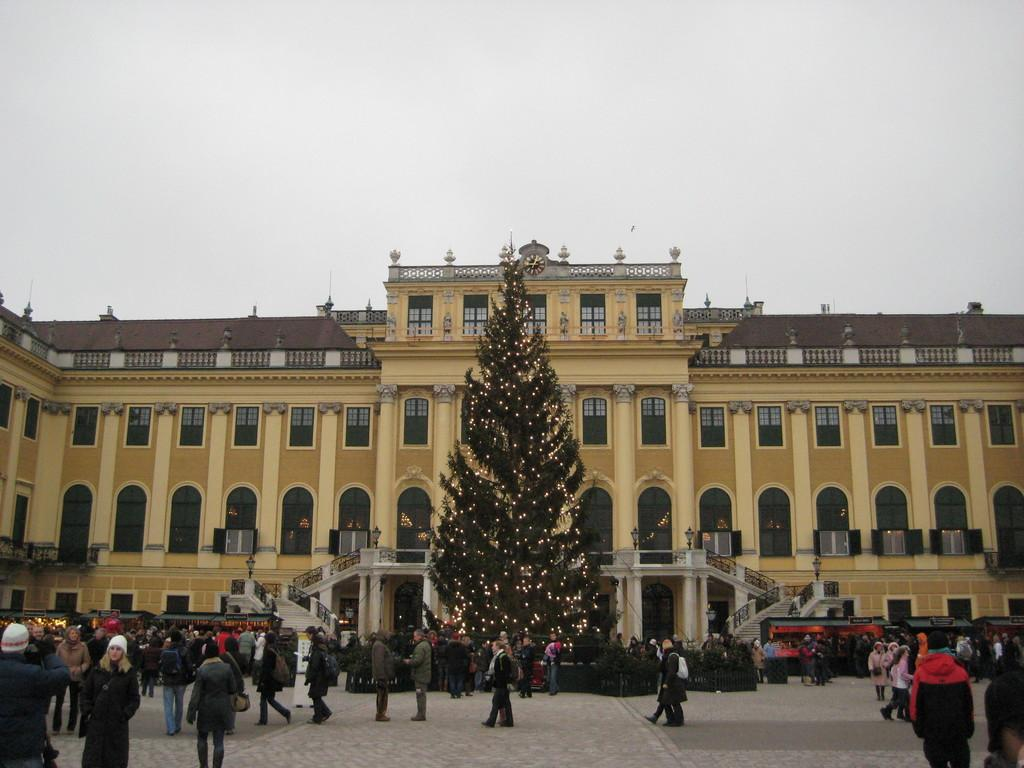What type of building is visible in the image? There is a building with glass windows in the image. What is located in the middle of the image? There is an Xmas tree with lights in the middle of the image. How many people are present in the image? There is a huge crowd of people in the image. What can be seen in the background of the image? The sky is visible in the image. What type of pest can be seen crawling on the Xmas tree in the image? There are no pests visible on the Xmas tree in the image. How does the behavior of the crowd of people differ from that of a typical family gathering? The image does not provide information about the behavior of the crowd or a typical family gathering, so it cannot be compared. 